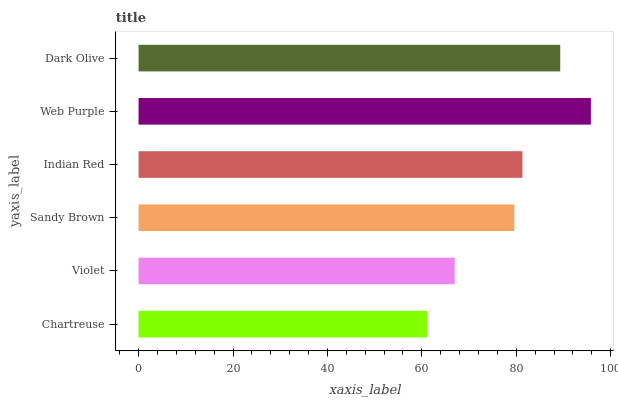Is Chartreuse the minimum?
Answer yes or no. Yes. Is Web Purple the maximum?
Answer yes or no. Yes. Is Violet the minimum?
Answer yes or no. No. Is Violet the maximum?
Answer yes or no. No. Is Violet greater than Chartreuse?
Answer yes or no. Yes. Is Chartreuse less than Violet?
Answer yes or no. Yes. Is Chartreuse greater than Violet?
Answer yes or no. No. Is Violet less than Chartreuse?
Answer yes or no. No. Is Indian Red the high median?
Answer yes or no. Yes. Is Sandy Brown the low median?
Answer yes or no. Yes. Is Violet the high median?
Answer yes or no. No. Is Web Purple the low median?
Answer yes or no. No. 